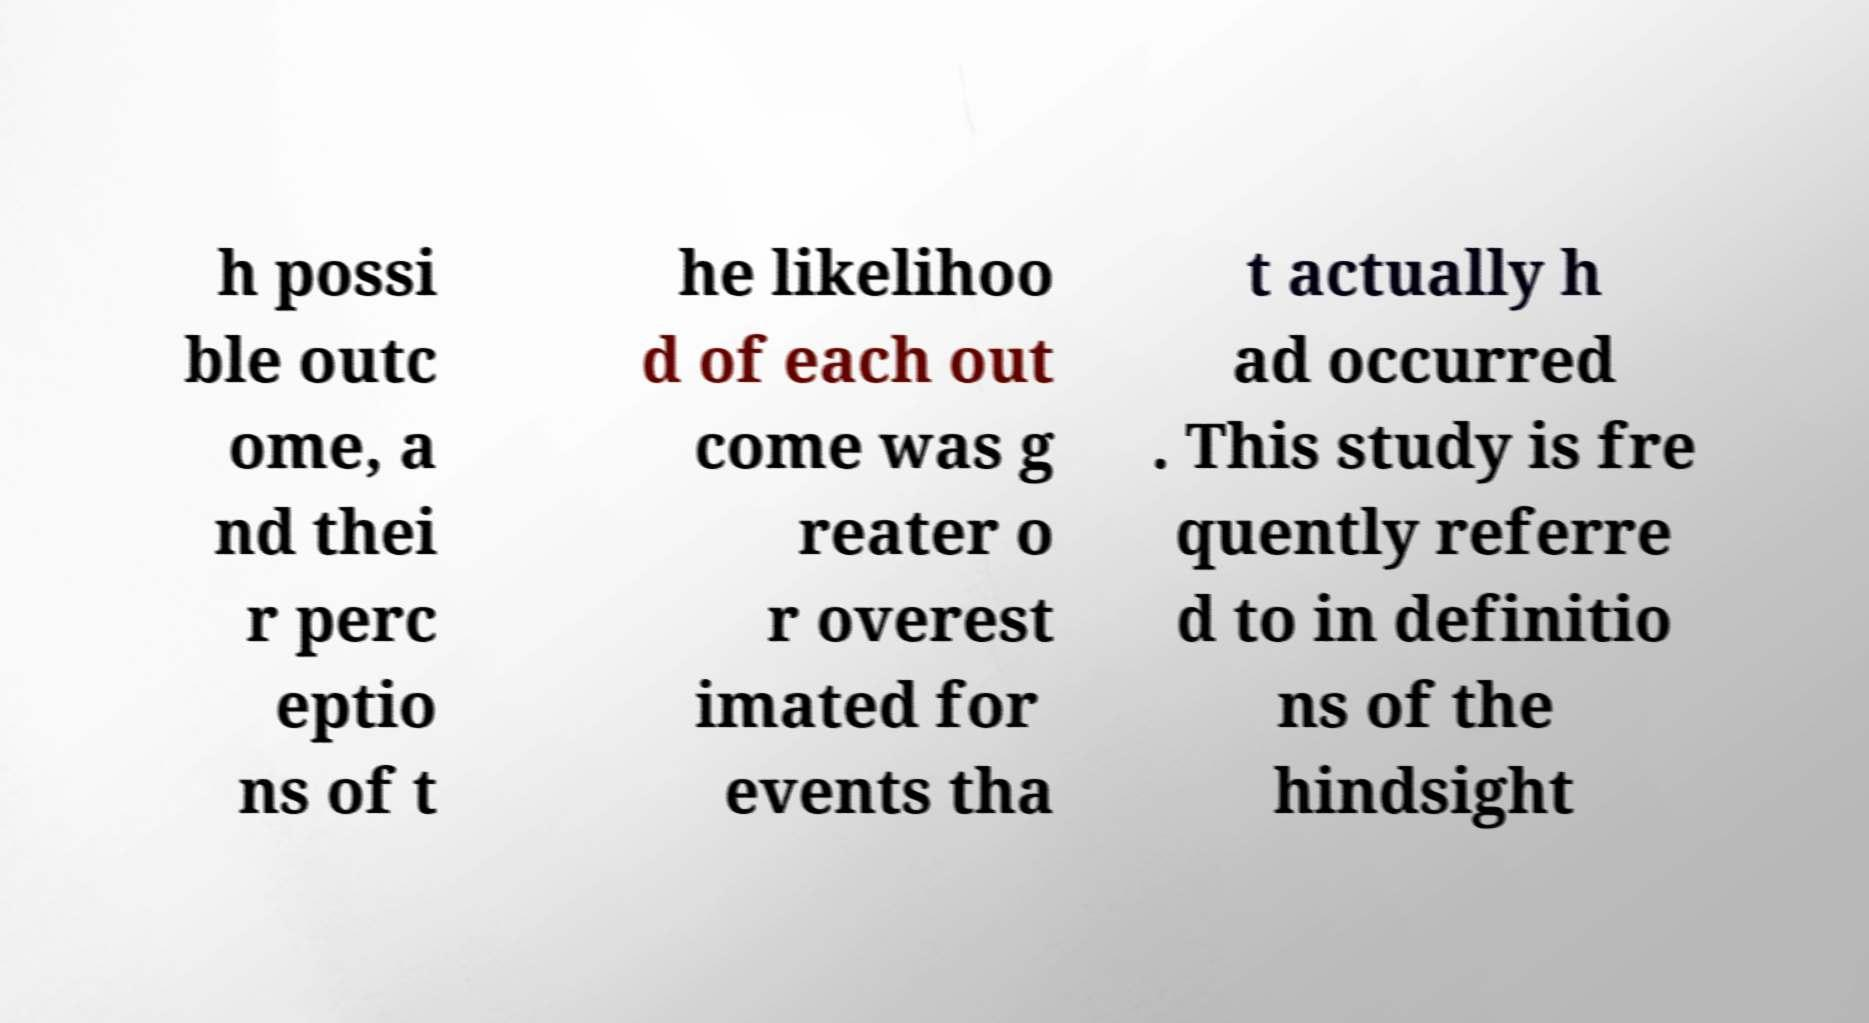Could you extract and type out the text from this image? h possi ble outc ome, a nd thei r perc eptio ns of t he likelihoo d of each out come was g reater o r overest imated for events tha t actually h ad occurred . This study is fre quently referre d to in definitio ns of the hindsight 